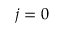Convert formula to latex. <formula><loc_0><loc_0><loc_500><loc_500>j = 0</formula> 